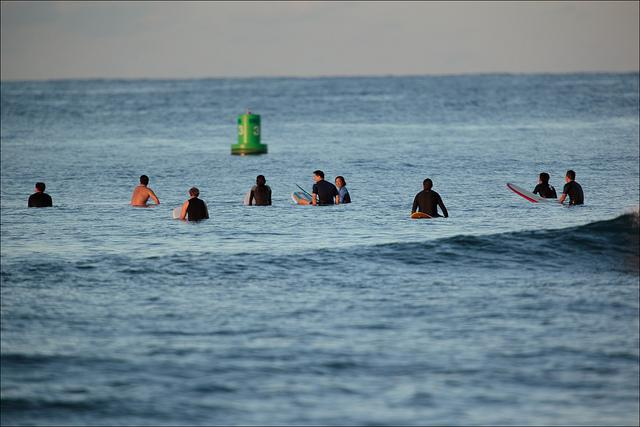Where are the people hanging out?

Choices:
A) bathroom
B) water
C) sand
D) restaurant water 